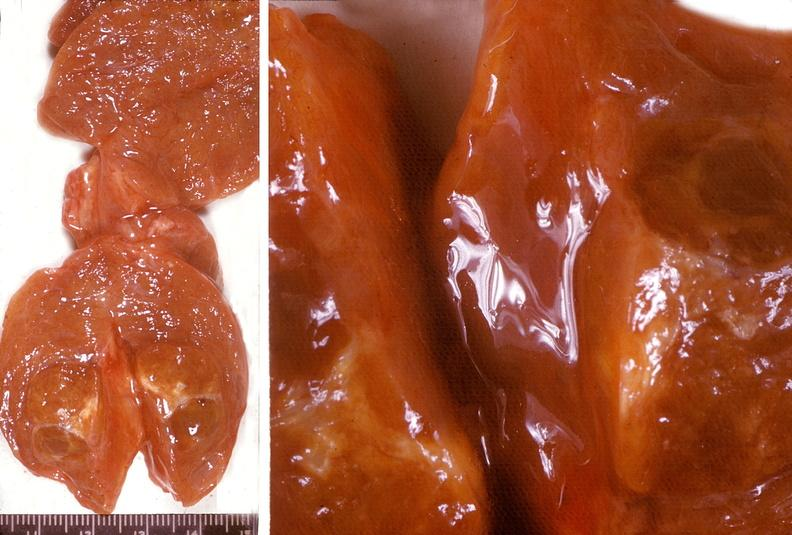does this image show thyroid, nodular colloid goiter?
Answer the question using a single word or phrase. Yes 